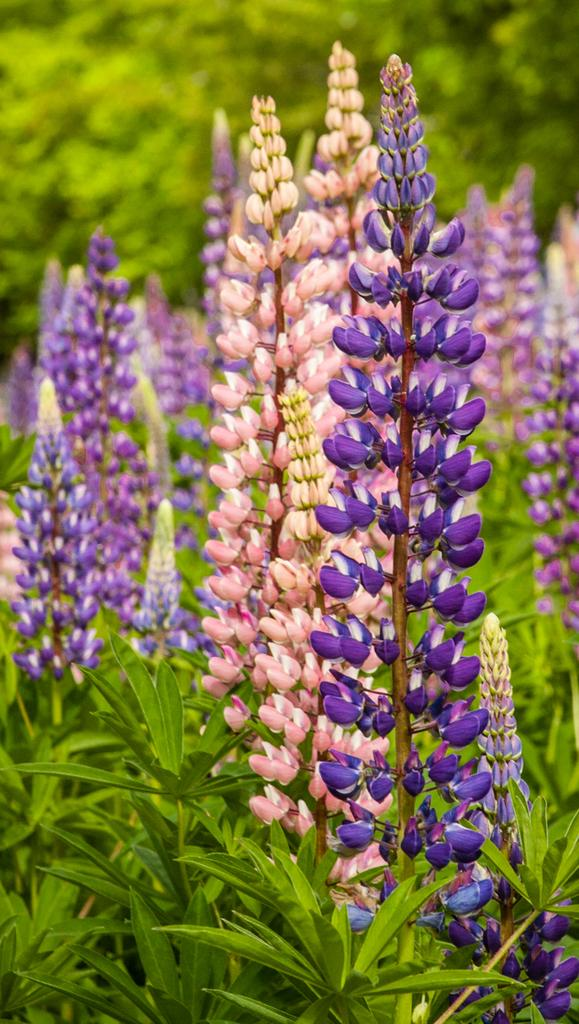What type of living organisms can be seen in the image? Plants and flowers are visible in the image. What is the relationship between the plants and the flowers in the image? The flowers are associated with the plants in the image. What can be seen in the background of the image? Trees are visible in the background of the image. What type of camera can be seen in the image? There is no camera present in the image. What memories are associated with the plants and flowers in the image? The image does not provide any information about memories associated with the plants and flowers. 